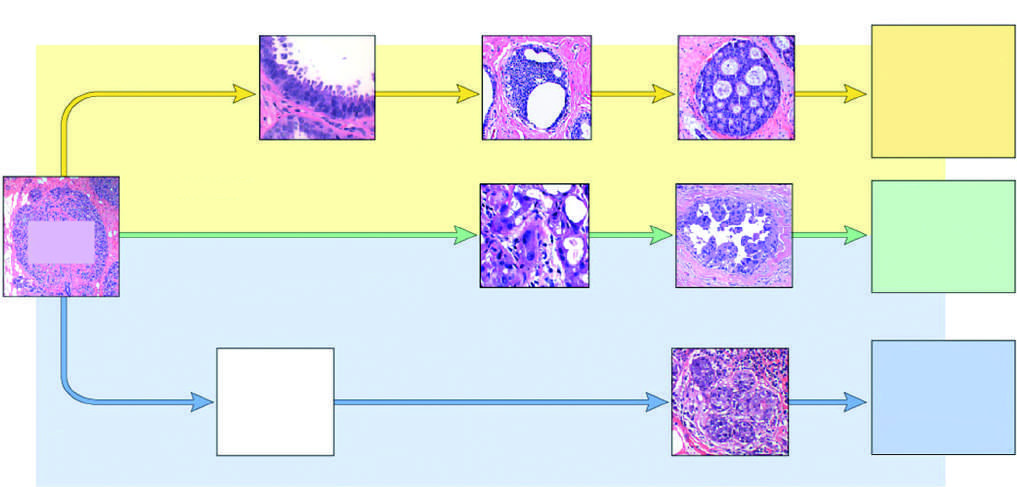what do morphologically recognized precursor lesions include?
Answer the question using a single word or phrase. Flat epithelial atypia 